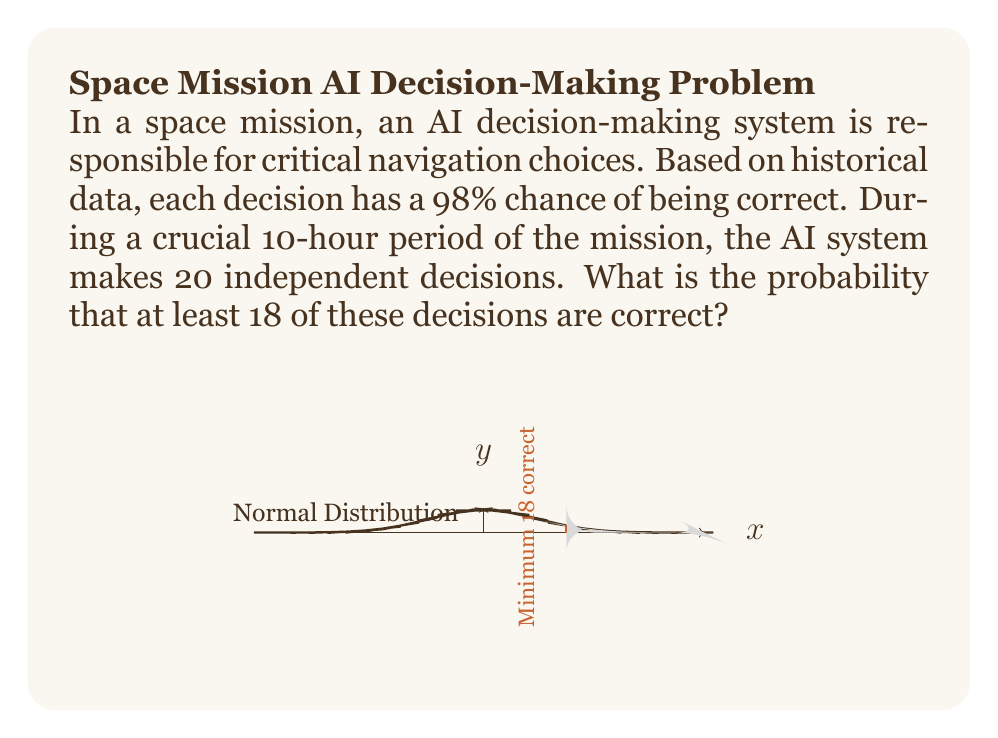Give your solution to this math problem. Let's approach this step-by-step using the binomial probability distribution:

1) We can model this scenario as a binomial distribution with:
   $n = 20$ (total number of decisions)
   $p = 0.98$ (probability of a correct decision)
   $X$ = number of correct decisions

2) We want to find $P(X \geq 18)$

3) This can be calculated as:
   $P(X \geq 18) = 1 - P(X < 18) = 1 - P(X \leq 17)$

4) The probability mass function for a binomial distribution is:
   $P(X = k) = \binom{n}{k} p^k (1-p)^{n-k}$

5) Therefore:
   $$P(X \geq 18) = 1 - \sum_{k=0}^{17} \binom{20}{k} (0.98)^k (0.02)^{20-k}$$

6) This sum is tedious to calculate by hand, so we typically use statistical software or tables. However, we can approximate it using the normal distribution:

7) For a binomial distribution, $\mu = np$ and $\sigma = \sqrt{np(1-p)}$
   $\mu = 20 * 0.98 = 19.6$
   $\sigma = \sqrt{20 * 0.98 * 0.02} \approx 0.626$

8) We can use the continuity correction and calculate:
   $P(X \geq 18) \approx P(Z \geq \frac{17.5 - 19.6}{0.626}) = P(Z \geq -3.35)$

9) From the standard normal table, $P(Z \geq -3.35) \approx 0.9996$

Therefore, the probability that at least 18 out of 20 decisions are correct is approximately 0.9996 or 99.96%.
Answer: 0.9996 